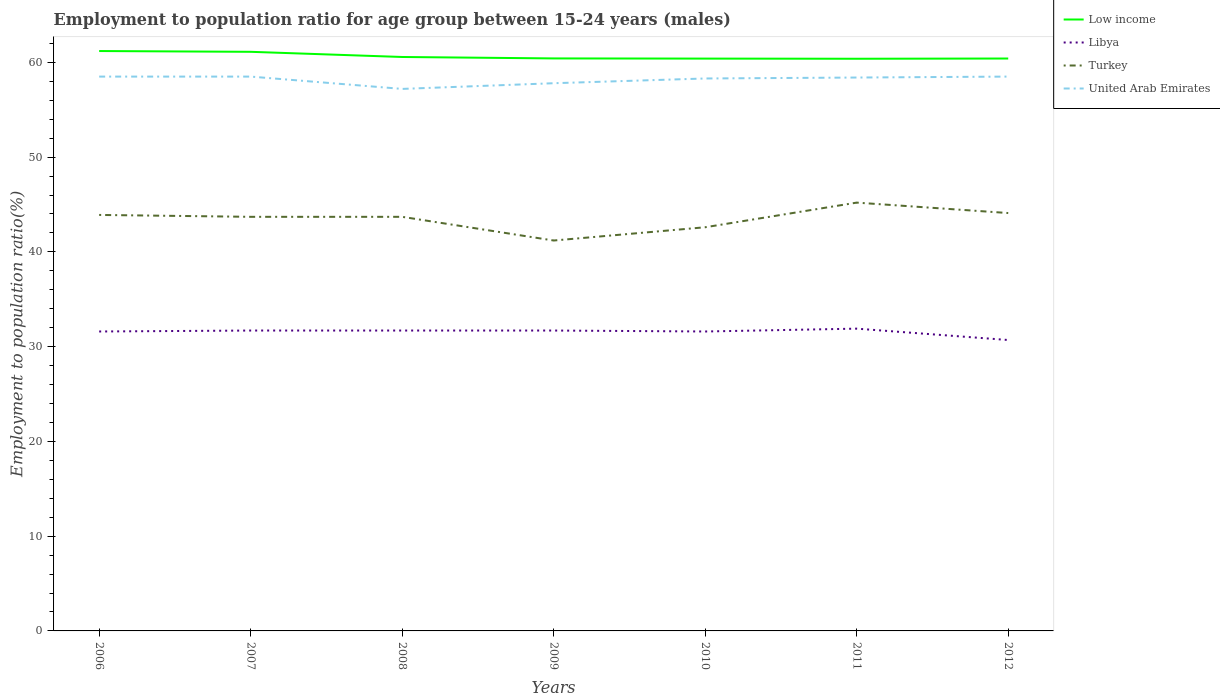How many different coloured lines are there?
Make the answer very short. 4. Is the number of lines equal to the number of legend labels?
Offer a terse response. Yes. Across all years, what is the maximum employment to population ratio in Turkey?
Make the answer very short. 41.2. In which year was the employment to population ratio in United Arab Emirates maximum?
Your response must be concise. 2008. What is the total employment to population ratio in Low income in the graph?
Provide a short and direct response. 0.15. What is the difference between the highest and the second highest employment to population ratio in Low income?
Offer a terse response. 0.82. Is the employment to population ratio in Turkey strictly greater than the employment to population ratio in United Arab Emirates over the years?
Offer a very short reply. Yes. How many years are there in the graph?
Offer a very short reply. 7. What is the difference between two consecutive major ticks on the Y-axis?
Offer a terse response. 10. Are the values on the major ticks of Y-axis written in scientific E-notation?
Provide a succinct answer. No. Does the graph contain any zero values?
Offer a terse response. No. How many legend labels are there?
Your answer should be compact. 4. How are the legend labels stacked?
Provide a succinct answer. Vertical. What is the title of the graph?
Ensure brevity in your answer.  Employment to population ratio for age group between 15-24 years (males). Does "Iran" appear as one of the legend labels in the graph?
Ensure brevity in your answer.  No. What is the label or title of the X-axis?
Offer a very short reply. Years. What is the Employment to population ratio(%) in Low income in 2006?
Make the answer very short. 61.2. What is the Employment to population ratio(%) of Libya in 2006?
Offer a terse response. 31.6. What is the Employment to population ratio(%) of Turkey in 2006?
Offer a very short reply. 43.9. What is the Employment to population ratio(%) in United Arab Emirates in 2006?
Your answer should be compact. 58.5. What is the Employment to population ratio(%) of Low income in 2007?
Your answer should be compact. 61.11. What is the Employment to population ratio(%) in Libya in 2007?
Make the answer very short. 31.7. What is the Employment to population ratio(%) in Turkey in 2007?
Your answer should be compact. 43.7. What is the Employment to population ratio(%) in United Arab Emirates in 2007?
Provide a short and direct response. 58.5. What is the Employment to population ratio(%) of Low income in 2008?
Keep it short and to the point. 60.57. What is the Employment to population ratio(%) of Libya in 2008?
Keep it short and to the point. 31.7. What is the Employment to population ratio(%) in Turkey in 2008?
Give a very brief answer. 43.7. What is the Employment to population ratio(%) in United Arab Emirates in 2008?
Your answer should be very brief. 57.2. What is the Employment to population ratio(%) in Low income in 2009?
Offer a very short reply. 60.42. What is the Employment to population ratio(%) of Libya in 2009?
Your response must be concise. 31.7. What is the Employment to population ratio(%) in Turkey in 2009?
Provide a succinct answer. 41.2. What is the Employment to population ratio(%) of United Arab Emirates in 2009?
Offer a very short reply. 57.8. What is the Employment to population ratio(%) in Low income in 2010?
Provide a short and direct response. 60.4. What is the Employment to population ratio(%) in Libya in 2010?
Offer a terse response. 31.6. What is the Employment to population ratio(%) in Turkey in 2010?
Keep it short and to the point. 42.6. What is the Employment to population ratio(%) in United Arab Emirates in 2010?
Give a very brief answer. 58.3. What is the Employment to population ratio(%) of Low income in 2011?
Offer a very short reply. 60.38. What is the Employment to population ratio(%) in Libya in 2011?
Provide a succinct answer. 31.9. What is the Employment to population ratio(%) in Turkey in 2011?
Your answer should be very brief. 45.2. What is the Employment to population ratio(%) of United Arab Emirates in 2011?
Your response must be concise. 58.4. What is the Employment to population ratio(%) in Low income in 2012?
Your answer should be compact. 60.41. What is the Employment to population ratio(%) in Libya in 2012?
Your response must be concise. 30.7. What is the Employment to population ratio(%) of Turkey in 2012?
Provide a succinct answer. 44.1. What is the Employment to population ratio(%) in United Arab Emirates in 2012?
Provide a short and direct response. 58.5. Across all years, what is the maximum Employment to population ratio(%) in Low income?
Your answer should be compact. 61.2. Across all years, what is the maximum Employment to population ratio(%) in Libya?
Offer a very short reply. 31.9. Across all years, what is the maximum Employment to population ratio(%) in Turkey?
Offer a terse response. 45.2. Across all years, what is the maximum Employment to population ratio(%) in United Arab Emirates?
Keep it short and to the point. 58.5. Across all years, what is the minimum Employment to population ratio(%) in Low income?
Your response must be concise. 60.38. Across all years, what is the minimum Employment to population ratio(%) in Libya?
Provide a short and direct response. 30.7. Across all years, what is the minimum Employment to population ratio(%) in Turkey?
Your answer should be very brief. 41.2. Across all years, what is the minimum Employment to population ratio(%) in United Arab Emirates?
Ensure brevity in your answer.  57.2. What is the total Employment to population ratio(%) in Low income in the graph?
Your answer should be very brief. 424.49. What is the total Employment to population ratio(%) of Libya in the graph?
Provide a succinct answer. 220.9. What is the total Employment to population ratio(%) in Turkey in the graph?
Make the answer very short. 304.4. What is the total Employment to population ratio(%) in United Arab Emirates in the graph?
Provide a short and direct response. 407.2. What is the difference between the Employment to population ratio(%) in Low income in 2006 and that in 2007?
Make the answer very short. 0.08. What is the difference between the Employment to population ratio(%) in Turkey in 2006 and that in 2007?
Your answer should be very brief. 0.2. What is the difference between the Employment to population ratio(%) in Low income in 2006 and that in 2008?
Give a very brief answer. 0.63. What is the difference between the Employment to population ratio(%) in Libya in 2006 and that in 2008?
Offer a terse response. -0.1. What is the difference between the Employment to population ratio(%) of United Arab Emirates in 2006 and that in 2008?
Provide a short and direct response. 1.3. What is the difference between the Employment to population ratio(%) of Low income in 2006 and that in 2009?
Offer a very short reply. 0.78. What is the difference between the Employment to population ratio(%) of Libya in 2006 and that in 2009?
Make the answer very short. -0.1. What is the difference between the Employment to population ratio(%) in Low income in 2006 and that in 2010?
Your answer should be compact. 0.8. What is the difference between the Employment to population ratio(%) in Libya in 2006 and that in 2010?
Provide a succinct answer. 0. What is the difference between the Employment to population ratio(%) in Low income in 2006 and that in 2011?
Your response must be concise. 0.82. What is the difference between the Employment to population ratio(%) of Libya in 2006 and that in 2011?
Provide a short and direct response. -0.3. What is the difference between the Employment to population ratio(%) of Turkey in 2006 and that in 2011?
Make the answer very short. -1.3. What is the difference between the Employment to population ratio(%) in Low income in 2006 and that in 2012?
Keep it short and to the point. 0.79. What is the difference between the Employment to population ratio(%) in Turkey in 2006 and that in 2012?
Keep it short and to the point. -0.2. What is the difference between the Employment to population ratio(%) of Low income in 2007 and that in 2008?
Give a very brief answer. 0.55. What is the difference between the Employment to population ratio(%) of Libya in 2007 and that in 2008?
Provide a succinct answer. 0. What is the difference between the Employment to population ratio(%) of Turkey in 2007 and that in 2008?
Provide a short and direct response. 0. What is the difference between the Employment to population ratio(%) of United Arab Emirates in 2007 and that in 2008?
Provide a succinct answer. 1.3. What is the difference between the Employment to population ratio(%) of Low income in 2007 and that in 2009?
Your answer should be compact. 0.7. What is the difference between the Employment to population ratio(%) in Turkey in 2007 and that in 2009?
Your answer should be compact. 2.5. What is the difference between the Employment to population ratio(%) of United Arab Emirates in 2007 and that in 2009?
Your answer should be compact. 0.7. What is the difference between the Employment to population ratio(%) in Low income in 2007 and that in 2010?
Give a very brief answer. 0.72. What is the difference between the Employment to population ratio(%) in United Arab Emirates in 2007 and that in 2010?
Keep it short and to the point. 0.2. What is the difference between the Employment to population ratio(%) of Low income in 2007 and that in 2011?
Give a very brief answer. 0.73. What is the difference between the Employment to population ratio(%) in Libya in 2007 and that in 2011?
Make the answer very short. -0.2. What is the difference between the Employment to population ratio(%) of Turkey in 2007 and that in 2011?
Your answer should be very brief. -1.5. What is the difference between the Employment to population ratio(%) in Low income in 2007 and that in 2012?
Offer a very short reply. 0.71. What is the difference between the Employment to population ratio(%) of Libya in 2007 and that in 2012?
Keep it short and to the point. 1. What is the difference between the Employment to population ratio(%) in Turkey in 2007 and that in 2012?
Offer a terse response. -0.4. What is the difference between the Employment to population ratio(%) of United Arab Emirates in 2007 and that in 2012?
Provide a short and direct response. 0. What is the difference between the Employment to population ratio(%) in Low income in 2008 and that in 2009?
Give a very brief answer. 0.15. What is the difference between the Employment to population ratio(%) of Libya in 2008 and that in 2009?
Keep it short and to the point. 0. What is the difference between the Employment to population ratio(%) of United Arab Emirates in 2008 and that in 2009?
Give a very brief answer. -0.6. What is the difference between the Employment to population ratio(%) in Low income in 2008 and that in 2010?
Give a very brief answer. 0.17. What is the difference between the Employment to population ratio(%) in Libya in 2008 and that in 2010?
Keep it short and to the point. 0.1. What is the difference between the Employment to population ratio(%) of United Arab Emirates in 2008 and that in 2010?
Provide a succinct answer. -1.1. What is the difference between the Employment to population ratio(%) of Low income in 2008 and that in 2011?
Offer a very short reply. 0.19. What is the difference between the Employment to population ratio(%) in Libya in 2008 and that in 2011?
Your answer should be very brief. -0.2. What is the difference between the Employment to population ratio(%) of Turkey in 2008 and that in 2011?
Your response must be concise. -1.5. What is the difference between the Employment to population ratio(%) in Low income in 2008 and that in 2012?
Make the answer very short. 0.16. What is the difference between the Employment to population ratio(%) of United Arab Emirates in 2008 and that in 2012?
Ensure brevity in your answer.  -1.3. What is the difference between the Employment to population ratio(%) in Low income in 2009 and that in 2010?
Make the answer very short. 0.02. What is the difference between the Employment to population ratio(%) of United Arab Emirates in 2009 and that in 2010?
Make the answer very short. -0.5. What is the difference between the Employment to population ratio(%) in Low income in 2009 and that in 2011?
Provide a succinct answer. 0.03. What is the difference between the Employment to population ratio(%) of Low income in 2009 and that in 2012?
Provide a short and direct response. 0.01. What is the difference between the Employment to population ratio(%) in Turkey in 2009 and that in 2012?
Provide a succinct answer. -2.9. What is the difference between the Employment to population ratio(%) in Low income in 2010 and that in 2011?
Provide a short and direct response. 0.02. What is the difference between the Employment to population ratio(%) in Turkey in 2010 and that in 2011?
Your response must be concise. -2.6. What is the difference between the Employment to population ratio(%) in United Arab Emirates in 2010 and that in 2011?
Your answer should be very brief. -0.1. What is the difference between the Employment to population ratio(%) in Low income in 2010 and that in 2012?
Your answer should be very brief. -0.01. What is the difference between the Employment to population ratio(%) in Libya in 2010 and that in 2012?
Provide a short and direct response. 0.9. What is the difference between the Employment to population ratio(%) of United Arab Emirates in 2010 and that in 2012?
Offer a very short reply. -0.2. What is the difference between the Employment to population ratio(%) in Low income in 2011 and that in 2012?
Provide a short and direct response. -0.02. What is the difference between the Employment to population ratio(%) in Libya in 2011 and that in 2012?
Your response must be concise. 1.2. What is the difference between the Employment to population ratio(%) in United Arab Emirates in 2011 and that in 2012?
Offer a terse response. -0.1. What is the difference between the Employment to population ratio(%) of Low income in 2006 and the Employment to population ratio(%) of Libya in 2007?
Your answer should be very brief. 29.5. What is the difference between the Employment to population ratio(%) in Low income in 2006 and the Employment to population ratio(%) in Turkey in 2007?
Your response must be concise. 17.5. What is the difference between the Employment to population ratio(%) in Low income in 2006 and the Employment to population ratio(%) in United Arab Emirates in 2007?
Make the answer very short. 2.7. What is the difference between the Employment to population ratio(%) in Libya in 2006 and the Employment to population ratio(%) in United Arab Emirates in 2007?
Offer a terse response. -26.9. What is the difference between the Employment to population ratio(%) in Turkey in 2006 and the Employment to population ratio(%) in United Arab Emirates in 2007?
Offer a very short reply. -14.6. What is the difference between the Employment to population ratio(%) of Low income in 2006 and the Employment to population ratio(%) of Libya in 2008?
Provide a succinct answer. 29.5. What is the difference between the Employment to population ratio(%) of Low income in 2006 and the Employment to population ratio(%) of Turkey in 2008?
Keep it short and to the point. 17.5. What is the difference between the Employment to population ratio(%) in Low income in 2006 and the Employment to population ratio(%) in United Arab Emirates in 2008?
Provide a short and direct response. 4. What is the difference between the Employment to population ratio(%) of Libya in 2006 and the Employment to population ratio(%) of Turkey in 2008?
Offer a terse response. -12.1. What is the difference between the Employment to population ratio(%) in Libya in 2006 and the Employment to population ratio(%) in United Arab Emirates in 2008?
Provide a short and direct response. -25.6. What is the difference between the Employment to population ratio(%) in Low income in 2006 and the Employment to population ratio(%) in Libya in 2009?
Your answer should be very brief. 29.5. What is the difference between the Employment to population ratio(%) of Low income in 2006 and the Employment to population ratio(%) of Turkey in 2009?
Your answer should be compact. 20. What is the difference between the Employment to population ratio(%) in Low income in 2006 and the Employment to population ratio(%) in United Arab Emirates in 2009?
Your answer should be very brief. 3.4. What is the difference between the Employment to population ratio(%) of Libya in 2006 and the Employment to population ratio(%) of United Arab Emirates in 2009?
Your answer should be compact. -26.2. What is the difference between the Employment to population ratio(%) of Turkey in 2006 and the Employment to population ratio(%) of United Arab Emirates in 2009?
Make the answer very short. -13.9. What is the difference between the Employment to population ratio(%) in Low income in 2006 and the Employment to population ratio(%) in Libya in 2010?
Make the answer very short. 29.6. What is the difference between the Employment to population ratio(%) of Low income in 2006 and the Employment to population ratio(%) of Turkey in 2010?
Ensure brevity in your answer.  18.6. What is the difference between the Employment to population ratio(%) in Low income in 2006 and the Employment to population ratio(%) in United Arab Emirates in 2010?
Make the answer very short. 2.9. What is the difference between the Employment to population ratio(%) in Libya in 2006 and the Employment to population ratio(%) in Turkey in 2010?
Provide a succinct answer. -11. What is the difference between the Employment to population ratio(%) of Libya in 2006 and the Employment to population ratio(%) of United Arab Emirates in 2010?
Give a very brief answer. -26.7. What is the difference between the Employment to population ratio(%) in Turkey in 2006 and the Employment to population ratio(%) in United Arab Emirates in 2010?
Keep it short and to the point. -14.4. What is the difference between the Employment to population ratio(%) of Low income in 2006 and the Employment to population ratio(%) of Libya in 2011?
Provide a succinct answer. 29.3. What is the difference between the Employment to population ratio(%) of Low income in 2006 and the Employment to population ratio(%) of Turkey in 2011?
Make the answer very short. 16. What is the difference between the Employment to population ratio(%) in Low income in 2006 and the Employment to population ratio(%) in United Arab Emirates in 2011?
Offer a terse response. 2.8. What is the difference between the Employment to population ratio(%) in Libya in 2006 and the Employment to population ratio(%) in United Arab Emirates in 2011?
Your response must be concise. -26.8. What is the difference between the Employment to population ratio(%) of Low income in 2006 and the Employment to population ratio(%) of Libya in 2012?
Provide a short and direct response. 30.5. What is the difference between the Employment to population ratio(%) in Low income in 2006 and the Employment to population ratio(%) in Turkey in 2012?
Keep it short and to the point. 17.1. What is the difference between the Employment to population ratio(%) of Low income in 2006 and the Employment to population ratio(%) of United Arab Emirates in 2012?
Offer a terse response. 2.7. What is the difference between the Employment to population ratio(%) in Libya in 2006 and the Employment to population ratio(%) in Turkey in 2012?
Offer a very short reply. -12.5. What is the difference between the Employment to population ratio(%) of Libya in 2006 and the Employment to population ratio(%) of United Arab Emirates in 2012?
Your response must be concise. -26.9. What is the difference between the Employment to population ratio(%) in Turkey in 2006 and the Employment to population ratio(%) in United Arab Emirates in 2012?
Give a very brief answer. -14.6. What is the difference between the Employment to population ratio(%) of Low income in 2007 and the Employment to population ratio(%) of Libya in 2008?
Your answer should be compact. 29.41. What is the difference between the Employment to population ratio(%) in Low income in 2007 and the Employment to population ratio(%) in Turkey in 2008?
Ensure brevity in your answer.  17.41. What is the difference between the Employment to population ratio(%) of Low income in 2007 and the Employment to population ratio(%) of United Arab Emirates in 2008?
Offer a very short reply. 3.91. What is the difference between the Employment to population ratio(%) of Libya in 2007 and the Employment to population ratio(%) of United Arab Emirates in 2008?
Your response must be concise. -25.5. What is the difference between the Employment to population ratio(%) of Low income in 2007 and the Employment to population ratio(%) of Libya in 2009?
Your response must be concise. 29.41. What is the difference between the Employment to population ratio(%) of Low income in 2007 and the Employment to population ratio(%) of Turkey in 2009?
Keep it short and to the point. 19.91. What is the difference between the Employment to population ratio(%) in Low income in 2007 and the Employment to population ratio(%) in United Arab Emirates in 2009?
Provide a succinct answer. 3.31. What is the difference between the Employment to population ratio(%) in Libya in 2007 and the Employment to population ratio(%) in Turkey in 2009?
Offer a terse response. -9.5. What is the difference between the Employment to population ratio(%) of Libya in 2007 and the Employment to population ratio(%) of United Arab Emirates in 2009?
Give a very brief answer. -26.1. What is the difference between the Employment to population ratio(%) in Turkey in 2007 and the Employment to population ratio(%) in United Arab Emirates in 2009?
Your response must be concise. -14.1. What is the difference between the Employment to population ratio(%) in Low income in 2007 and the Employment to population ratio(%) in Libya in 2010?
Give a very brief answer. 29.51. What is the difference between the Employment to population ratio(%) in Low income in 2007 and the Employment to population ratio(%) in Turkey in 2010?
Make the answer very short. 18.51. What is the difference between the Employment to population ratio(%) of Low income in 2007 and the Employment to population ratio(%) of United Arab Emirates in 2010?
Provide a short and direct response. 2.81. What is the difference between the Employment to population ratio(%) of Libya in 2007 and the Employment to population ratio(%) of Turkey in 2010?
Provide a succinct answer. -10.9. What is the difference between the Employment to population ratio(%) in Libya in 2007 and the Employment to population ratio(%) in United Arab Emirates in 2010?
Provide a succinct answer. -26.6. What is the difference between the Employment to population ratio(%) of Turkey in 2007 and the Employment to population ratio(%) of United Arab Emirates in 2010?
Ensure brevity in your answer.  -14.6. What is the difference between the Employment to population ratio(%) of Low income in 2007 and the Employment to population ratio(%) of Libya in 2011?
Offer a very short reply. 29.21. What is the difference between the Employment to population ratio(%) of Low income in 2007 and the Employment to population ratio(%) of Turkey in 2011?
Offer a terse response. 15.91. What is the difference between the Employment to population ratio(%) in Low income in 2007 and the Employment to population ratio(%) in United Arab Emirates in 2011?
Your answer should be compact. 2.71. What is the difference between the Employment to population ratio(%) in Libya in 2007 and the Employment to population ratio(%) in Turkey in 2011?
Keep it short and to the point. -13.5. What is the difference between the Employment to population ratio(%) in Libya in 2007 and the Employment to population ratio(%) in United Arab Emirates in 2011?
Your response must be concise. -26.7. What is the difference between the Employment to population ratio(%) in Turkey in 2007 and the Employment to population ratio(%) in United Arab Emirates in 2011?
Provide a short and direct response. -14.7. What is the difference between the Employment to population ratio(%) in Low income in 2007 and the Employment to population ratio(%) in Libya in 2012?
Provide a succinct answer. 30.41. What is the difference between the Employment to population ratio(%) in Low income in 2007 and the Employment to population ratio(%) in Turkey in 2012?
Offer a very short reply. 17.01. What is the difference between the Employment to population ratio(%) of Low income in 2007 and the Employment to population ratio(%) of United Arab Emirates in 2012?
Give a very brief answer. 2.61. What is the difference between the Employment to population ratio(%) in Libya in 2007 and the Employment to population ratio(%) in Turkey in 2012?
Keep it short and to the point. -12.4. What is the difference between the Employment to population ratio(%) in Libya in 2007 and the Employment to population ratio(%) in United Arab Emirates in 2012?
Your response must be concise. -26.8. What is the difference between the Employment to population ratio(%) in Turkey in 2007 and the Employment to population ratio(%) in United Arab Emirates in 2012?
Your answer should be very brief. -14.8. What is the difference between the Employment to population ratio(%) in Low income in 2008 and the Employment to population ratio(%) in Libya in 2009?
Keep it short and to the point. 28.87. What is the difference between the Employment to population ratio(%) in Low income in 2008 and the Employment to population ratio(%) in Turkey in 2009?
Give a very brief answer. 19.37. What is the difference between the Employment to population ratio(%) in Low income in 2008 and the Employment to population ratio(%) in United Arab Emirates in 2009?
Your answer should be compact. 2.77. What is the difference between the Employment to population ratio(%) of Libya in 2008 and the Employment to population ratio(%) of United Arab Emirates in 2009?
Your answer should be compact. -26.1. What is the difference between the Employment to population ratio(%) in Turkey in 2008 and the Employment to population ratio(%) in United Arab Emirates in 2009?
Ensure brevity in your answer.  -14.1. What is the difference between the Employment to population ratio(%) of Low income in 2008 and the Employment to population ratio(%) of Libya in 2010?
Provide a succinct answer. 28.97. What is the difference between the Employment to population ratio(%) of Low income in 2008 and the Employment to population ratio(%) of Turkey in 2010?
Your answer should be compact. 17.97. What is the difference between the Employment to population ratio(%) in Low income in 2008 and the Employment to population ratio(%) in United Arab Emirates in 2010?
Make the answer very short. 2.27. What is the difference between the Employment to population ratio(%) of Libya in 2008 and the Employment to population ratio(%) of Turkey in 2010?
Ensure brevity in your answer.  -10.9. What is the difference between the Employment to population ratio(%) of Libya in 2008 and the Employment to population ratio(%) of United Arab Emirates in 2010?
Offer a terse response. -26.6. What is the difference between the Employment to population ratio(%) in Turkey in 2008 and the Employment to population ratio(%) in United Arab Emirates in 2010?
Keep it short and to the point. -14.6. What is the difference between the Employment to population ratio(%) of Low income in 2008 and the Employment to population ratio(%) of Libya in 2011?
Offer a very short reply. 28.67. What is the difference between the Employment to population ratio(%) in Low income in 2008 and the Employment to population ratio(%) in Turkey in 2011?
Ensure brevity in your answer.  15.37. What is the difference between the Employment to population ratio(%) of Low income in 2008 and the Employment to population ratio(%) of United Arab Emirates in 2011?
Provide a succinct answer. 2.17. What is the difference between the Employment to population ratio(%) of Libya in 2008 and the Employment to population ratio(%) of Turkey in 2011?
Your answer should be very brief. -13.5. What is the difference between the Employment to population ratio(%) of Libya in 2008 and the Employment to population ratio(%) of United Arab Emirates in 2011?
Your answer should be compact. -26.7. What is the difference between the Employment to population ratio(%) in Turkey in 2008 and the Employment to population ratio(%) in United Arab Emirates in 2011?
Ensure brevity in your answer.  -14.7. What is the difference between the Employment to population ratio(%) of Low income in 2008 and the Employment to population ratio(%) of Libya in 2012?
Offer a terse response. 29.87. What is the difference between the Employment to population ratio(%) of Low income in 2008 and the Employment to population ratio(%) of Turkey in 2012?
Ensure brevity in your answer.  16.47. What is the difference between the Employment to population ratio(%) in Low income in 2008 and the Employment to population ratio(%) in United Arab Emirates in 2012?
Your response must be concise. 2.07. What is the difference between the Employment to population ratio(%) in Libya in 2008 and the Employment to population ratio(%) in Turkey in 2012?
Keep it short and to the point. -12.4. What is the difference between the Employment to population ratio(%) of Libya in 2008 and the Employment to population ratio(%) of United Arab Emirates in 2012?
Your answer should be compact. -26.8. What is the difference between the Employment to population ratio(%) in Turkey in 2008 and the Employment to population ratio(%) in United Arab Emirates in 2012?
Offer a terse response. -14.8. What is the difference between the Employment to population ratio(%) in Low income in 2009 and the Employment to population ratio(%) in Libya in 2010?
Make the answer very short. 28.82. What is the difference between the Employment to population ratio(%) in Low income in 2009 and the Employment to population ratio(%) in Turkey in 2010?
Offer a very short reply. 17.82. What is the difference between the Employment to population ratio(%) in Low income in 2009 and the Employment to population ratio(%) in United Arab Emirates in 2010?
Provide a short and direct response. 2.12. What is the difference between the Employment to population ratio(%) in Libya in 2009 and the Employment to population ratio(%) in United Arab Emirates in 2010?
Keep it short and to the point. -26.6. What is the difference between the Employment to population ratio(%) in Turkey in 2009 and the Employment to population ratio(%) in United Arab Emirates in 2010?
Your answer should be very brief. -17.1. What is the difference between the Employment to population ratio(%) of Low income in 2009 and the Employment to population ratio(%) of Libya in 2011?
Your response must be concise. 28.52. What is the difference between the Employment to population ratio(%) in Low income in 2009 and the Employment to population ratio(%) in Turkey in 2011?
Provide a short and direct response. 15.22. What is the difference between the Employment to population ratio(%) in Low income in 2009 and the Employment to population ratio(%) in United Arab Emirates in 2011?
Provide a succinct answer. 2.02. What is the difference between the Employment to population ratio(%) of Libya in 2009 and the Employment to population ratio(%) of United Arab Emirates in 2011?
Your answer should be very brief. -26.7. What is the difference between the Employment to population ratio(%) of Turkey in 2009 and the Employment to population ratio(%) of United Arab Emirates in 2011?
Keep it short and to the point. -17.2. What is the difference between the Employment to population ratio(%) of Low income in 2009 and the Employment to population ratio(%) of Libya in 2012?
Offer a very short reply. 29.72. What is the difference between the Employment to population ratio(%) in Low income in 2009 and the Employment to population ratio(%) in Turkey in 2012?
Ensure brevity in your answer.  16.32. What is the difference between the Employment to population ratio(%) in Low income in 2009 and the Employment to population ratio(%) in United Arab Emirates in 2012?
Keep it short and to the point. 1.92. What is the difference between the Employment to population ratio(%) of Libya in 2009 and the Employment to population ratio(%) of United Arab Emirates in 2012?
Your answer should be very brief. -26.8. What is the difference between the Employment to population ratio(%) in Turkey in 2009 and the Employment to population ratio(%) in United Arab Emirates in 2012?
Provide a succinct answer. -17.3. What is the difference between the Employment to population ratio(%) of Low income in 2010 and the Employment to population ratio(%) of Libya in 2011?
Keep it short and to the point. 28.5. What is the difference between the Employment to population ratio(%) of Low income in 2010 and the Employment to population ratio(%) of Turkey in 2011?
Your answer should be compact. 15.2. What is the difference between the Employment to population ratio(%) of Low income in 2010 and the Employment to population ratio(%) of United Arab Emirates in 2011?
Your answer should be compact. 2. What is the difference between the Employment to population ratio(%) of Libya in 2010 and the Employment to population ratio(%) of Turkey in 2011?
Keep it short and to the point. -13.6. What is the difference between the Employment to population ratio(%) in Libya in 2010 and the Employment to population ratio(%) in United Arab Emirates in 2011?
Make the answer very short. -26.8. What is the difference between the Employment to population ratio(%) in Turkey in 2010 and the Employment to population ratio(%) in United Arab Emirates in 2011?
Your answer should be very brief. -15.8. What is the difference between the Employment to population ratio(%) in Low income in 2010 and the Employment to population ratio(%) in Libya in 2012?
Your answer should be compact. 29.7. What is the difference between the Employment to population ratio(%) in Low income in 2010 and the Employment to population ratio(%) in Turkey in 2012?
Ensure brevity in your answer.  16.3. What is the difference between the Employment to population ratio(%) of Low income in 2010 and the Employment to population ratio(%) of United Arab Emirates in 2012?
Keep it short and to the point. 1.9. What is the difference between the Employment to population ratio(%) in Libya in 2010 and the Employment to population ratio(%) in United Arab Emirates in 2012?
Ensure brevity in your answer.  -26.9. What is the difference between the Employment to population ratio(%) in Turkey in 2010 and the Employment to population ratio(%) in United Arab Emirates in 2012?
Provide a succinct answer. -15.9. What is the difference between the Employment to population ratio(%) in Low income in 2011 and the Employment to population ratio(%) in Libya in 2012?
Keep it short and to the point. 29.68. What is the difference between the Employment to population ratio(%) of Low income in 2011 and the Employment to population ratio(%) of Turkey in 2012?
Keep it short and to the point. 16.28. What is the difference between the Employment to population ratio(%) of Low income in 2011 and the Employment to population ratio(%) of United Arab Emirates in 2012?
Provide a succinct answer. 1.88. What is the difference between the Employment to population ratio(%) in Libya in 2011 and the Employment to population ratio(%) in United Arab Emirates in 2012?
Your response must be concise. -26.6. What is the average Employment to population ratio(%) in Low income per year?
Provide a short and direct response. 60.64. What is the average Employment to population ratio(%) in Libya per year?
Ensure brevity in your answer.  31.56. What is the average Employment to population ratio(%) in Turkey per year?
Provide a succinct answer. 43.49. What is the average Employment to population ratio(%) in United Arab Emirates per year?
Your answer should be very brief. 58.17. In the year 2006, what is the difference between the Employment to population ratio(%) in Low income and Employment to population ratio(%) in Libya?
Provide a short and direct response. 29.6. In the year 2006, what is the difference between the Employment to population ratio(%) in Low income and Employment to population ratio(%) in Turkey?
Offer a terse response. 17.3. In the year 2006, what is the difference between the Employment to population ratio(%) in Low income and Employment to population ratio(%) in United Arab Emirates?
Ensure brevity in your answer.  2.7. In the year 2006, what is the difference between the Employment to population ratio(%) in Libya and Employment to population ratio(%) in Turkey?
Offer a terse response. -12.3. In the year 2006, what is the difference between the Employment to population ratio(%) of Libya and Employment to population ratio(%) of United Arab Emirates?
Provide a short and direct response. -26.9. In the year 2006, what is the difference between the Employment to population ratio(%) of Turkey and Employment to population ratio(%) of United Arab Emirates?
Give a very brief answer. -14.6. In the year 2007, what is the difference between the Employment to population ratio(%) in Low income and Employment to population ratio(%) in Libya?
Offer a very short reply. 29.41. In the year 2007, what is the difference between the Employment to population ratio(%) in Low income and Employment to population ratio(%) in Turkey?
Provide a short and direct response. 17.41. In the year 2007, what is the difference between the Employment to population ratio(%) in Low income and Employment to population ratio(%) in United Arab Emirates?
Keep it short and to the point. 2.61. In the year 2007, what is the difference between the Employment to population ratio(%) of Libya and Employment to population ratio(%) of Turkey?
Make the answer very short. -12. In the year 2007, what is the difference between the Employment to population ratio(%) of Libya and Employment to population ratio(%) of United Arab Emirates?
Offer a terse response. -26.8. In the year 2007, what is the difference between the Employment to population ratio(%) in Turkey and Employment to population ratio(%) in United Arab Emirates?
Your answer should be very brief. -14.8. In the year 2008, what is the difference between the Employment to population ratio(%) of Low income and Employment to population ratio(%) of Libya?
Ensure brevity in your answer.  28.87. In the year 2008, what is the difference between the Employment to population ratio(%) of Low income and Employment to population ratio(%) of Turkey?
Provide a succinct answer. 16.87. In the year 2008, what is the difference between the Employment to population ratio(%) in Low income and Employment to population ratio(%) in United Arab Emirates?
Your answer should be compact. 3.37. In the year 2008, what is the difference between the Employment to population ratio(%) in Libya and Employment to population ratio(%) in Turkey?
Offer a terse response. -12. In the year 2008, what is the difference between the Employment to population ratio(%) of Libya and Employment to population ratio(%) of United Arab Emirates?
Your answer should be compact. -25.5. In the year 2008, what is the difference between the Employment to population ratio(%) of Turkey and Employment to population ratio(%) of United Arab Emirates?
Your response must be concise. -13.5. In the year 2009, what is the difference between the Employment to population ratio(%) in Low income and Employment to population ratio(%) in Libya?
Offer a terse response. 28.72. In the year 2009, what is the difference between the Employment to population ratio(%) in Low income and Employment to population ratio(%) in Turkey?
Make the answer very short. 19.22. In the year 2009, what is the difference between the Employment to population ratio(%) in Low income and Employment to population ratio(%) in United Arab Emirates?
Your answer should be compact. 2.62. In the year 2009, what is the difference between the Employment to population ratio(%) in Libya and Employment to population ratio(%) in Turkey?
Give a very brief answer. -9.5. In the year 2009, what is the difference between the Employment to population ratio(%) in Libya and Employment to population ratio(%) in United Arab Emirates?
Offer a very short reply. -26.1. In the year 2009, what is the difference between the Employment to population ratio(%) in Turkey and Employment to population ratio(%) in United Arab Emirates?
Your answer should be compact. -16.6. In the year 2010, what is the difference between the Employment to population ratio(%) in Low income and Employment to population ratio(%) in Libya?
Make the answer very short. 28.8. In the year 2010, what is the difference between the Employment to population ratio(%) of Low income and Employment to population ratio(%) of Turkey?
Your answer should be very brief. 17.8. In the year 2010, what is the difference between the Employment to population ratio(%) of Low income and Employment to population ratio(%) of United Arab Emirates?
Offer a terse response. 2.1. In the year 2010, what is the difference between the Employment to population ratio(%) of Libya and Employment to population ratio(%) of Turkey?
Ensure brevity in your answer.  -11. In the year 2010, what is the difference between the Employment to population ratio(%) of Libya and Employment to population ratio(%) of United Arab Emirates?
Give a very brief answer. -26.7. In the year 2010, what is the difference between the Employment to population ratio(%) in Turkey and Employment to population ratio(%) in United Arab Emirates?
Provide a succinct answer. -15.7. In the year 2011, what is the difference between the Employment to population ratio(%) in Low income and Employment to population ratio(%) in Libya?
Offer a very short reply. 28.48. In the year 2011, what is the difference between the Employment to population ratio(%) in Low income and Employment to population ratio(%) in Turkey?
Offer a very short reply. 15.18. In the year 2011, what is the difference between the Employment to population ratio(%) of Low income and Employment to population ratio(%) of United Arab Emirates?
Ensure brevity in your answer.  1.98. In the year 2011, what is the difference between the Employment to population ratio(%) of Libya and Employment to population ratio(%) of Turkey?
Your answer should be compact. -13.3. In the year 2011, what is the difference between the Employment to population ratio(%) in Libya and Employment to population ratio(%) in United Arab Emirates?
Make the answer very short. -26.5. In the year 2011, what is the difference between the Employment to population ratio(%) in Turkey and Employment to population ratio(%) in United Arab Emirates?
Keep it short and to the point. -13.2. In the year 2012, what is the difference between the Employment to population ratio(%) in Low income and Employment to population ratio(%) in Libya?
Make the answer very short. 29.71. In the year 2012, what is the difference between the Employment to population ratio(%) in Low income and Employment to population ratio(%) in Turkey?
Make the answer very short. 16.31. In the year 2012, what is the difference between the Employment to population ratio(%) of Low income and Employment to population ratio(%) of United Arab Emirates?
Offer a terse response. 1.91. In the year 2012, what is the difference between the Employment to population ratio(%) in Libya and Employment to population ratio(%) in United Arab Emirates?
Offer a terse response. -27.8. In the year 2012, what is the difference between the Employment to population ratio(%) in Turkey and Employment to population ratio(%) in United Arab Emirates?
Provide a succinct answer. -14.4. What is the ratio of the Employment to population ratio(%) of Low income in 2006 to that in 2007?
Keep it short and to the point. 1. What is the ratio of the Employment to population ratio(%) of Turkey in 2006 to that in 2007?
Your response must be concise. 1. What is the ratio of the Employment to population ratio(%) of United Arab Emirates in 2006 to that in 2007?
Offer a terse response. 1. What is the ratio of the Employment to population ratio(%) in Low income in 2006 to that in 2008?
Your response must be concise. 1.01. What is the ratio of the Employment to population ratio(%) of United Arab Emirates in 2006 to that in 2008?
Offer a very short reply. 1.02. What is the ratio of the Employment to population ratio(%) in Low income in 2006 to that in 2009?
Give a very brief answer. 1.01. What is the ratio of the Employment to population ratio(%) of Turkey in 2006 to that in 2009?
Keep it short and to the point. 1.07. What is the ratio of the Employment to population ratio(%) of United Arab Emirates in 2006 to that in 2009?
Offer a terse response. 1.01. What is the ratio of the Employment to population ratio(%) in Low income in 2006 to that in 2010?
Your answer should be very brief. 1.01. What is the ratio of the Employment to population ratio(%) of Turkey in 2006 to that in 2010?
Offer a very short reply. 1.03. What is the ratio of the Employment to population ratio(%) of Low income in 2006 to that in 2011?
Give a very brief answer. 1.01. What is the ratio of the Employment to population ratio(%) of Libya in 2006 to that in 2011?
Your answer should be very brief. 0.99. What is the ratio of the Employment to population ratio(%) of Turkey in 2006 to that in 2011?
Offer a terse response. 0.97. What is the ratio of the Employment to population ratio(%) in United Arab Emirates in 2006 to that in 2011?
Keep it short and to the point. 1. What is the ratio of the Employment to population ratio(%) of Low income in 2006 to that in 2012?
Give a very brief answer. 1.01. What is the ratio of the Employment to population ratio(%) of Libya in 2006 to that in 2012?
Provide a short and direct response. 1.03. What is the ratio of the Employment to population ratio(%) of Turkey in 2006 to that in 2012?
Give a very brief answer. 1. What is the ratio of the Employment to population ratio(%) in United Arab Emirates in 2006 to that in 2012?
Offer a very short reply. 1. What is the ratio of the Employment to population ratio(%) of Libya in 2007 to that in 2008?
Keep it short and to the point. 1. What is the ratio of the Employment to population ratio(%) of United Arab Emirates in 2007 to that in 2008?
Offer a terse response. 1.02. What is the ratio of the Employment to population ratio(%) in Low income in 2007 to that in 2009?
Provide a short and direct response. 1.01. What is the ratio of the Employment to population ratio(%) of Libya in 2007 to that in 2009?
Make the answer very short. 1. What is the ratio of the Employment to population ratio(%) in Turkey in 2007 to that in 2009?
Provide a short and direct response. 1.06. What is the ratio of the Employment to population ratio(%) in United Arab Emirates in 2007 to that in 2009?
Keep it short and to the point. 1.01. What is the ratio of the Employment to population ratio(%) in Low income in 2007 to that in 2010?
Give a very brief answer. 1.01. What is the ratio of the Employment to population ratio(%) of Libya in 2007 to that in 2010?
Your answer should be very brief. 1. What is the ratio of the Employment to population ratio(%) in Turkey in 2007 to that in 2010?
Offer a very short reply. 1.03. What is the ratio of the Employment to population ratio(%) in United Arab Emirates in 2007 to that in 2010?
Keep it short and to the point. 1. What is the ratio of the Employment to population ratio(%) in Low income in 2007 to that in 2011?
Ensure brevity in your answer.  1.01. What is the ratio of the Employment to population ratio(%) of Turkey in 2007 to that in 2011?
Make the answer very short. 0.97. What is the ratio of the Employment to population ratio(%) of United Arab Emirates in 2007 to that in 2011?
Your answer should be compact. 1. What is the ratio of the Employment to population ratio(%) of Low income in 2007 to that in 2012?
Ensure brevity in your answer.  1.01. What is the ratio of the Employment to population ratio(%) in Libya in 2007 to that in 2012?
Your answer should be very brief. 1.03. What is the ratio of the Employment to population ratio(%) in Turkey in 2007 to that in 2012?
Provide a succinct answer. 0.99. What is the ratio of the Employment to population ratio(%) in Low income in 2008 to that in 2009?
Your answer should be compact. 1. What is the ratio of the Employment to population ratio(%) in Libya in 2008 to that in 2009?
Offer a very short reply. 1. What is the ratio of the Employment to population ratio(%) of Turkey in 2008 to that in 2009?
Offer a terse response. 1.06. What is the ratio of the Employment to population ratio(%) of United Arab Emirates in 2008 to that in 2009?
Your answer should be very brief. 0.99. What is the ratio of the Employment to population ratio(%) of Turkey in 2008 to that in 2010?
Offer a terse response. 1.03. What is the ratio of the Employment to population ratio(%) of United Arab Emirates in 2008 to that in 2010?
Your answer should be very brief. 0.98. What is the ratio of the Employment to population ratio(%) in Low income in 2008 to that in 2011?
Your answer should be very brief. 1. What is the ratio of the Employment to population ratio(%) of Turkey in 2008 to that in 2011?
Your response must be concise. 0.97. What is the ratio of the Employment to population ratio(%) in United Arab Emirates in 2008 to that in 2011?
Your answer should be compact. 0.98. What is the ratio of the Employment to population ratio(%) of Low income in 2008 to that in 2012?
Provide a succinct answer. 1. What is the ratio of the Employment to population ratio(%) in Libya in 2008 to that in 2012?
Your response must be concise. 1.03. What is the ratio of the Employment to population ratio(%) of Turkey in 2008 to that in 2012?
Offer a very short reply. 0.99. What is the ratio of the Employment to population ratio(%) of United Arab Emirates in 2008 to that in 2012?
Give a very brief answer. 0.98. What is the ratio of the Employment to population ratio(%) of Low income in 2009 to that in 2010?
Your response must be concise. 1. What is the ratio of the Employment to population ratio(%) in Turkey in 2009 to that in 2010?
Provide a succinct answer. 0.97. What is the ratio of the Employment to population ratio(%) in Turkey in 2009 to that in 2011?
Your response must be concise. 0.91. What is the ratio of the Employment to population ratio(%) of United Arab Emirates in 2009 to that in 2011?
Offer a terse response. 0.99. What is the ratio of the Employment to population ratio(%) of Libya in 2009 to that in 2012?
Your answer should be compact. 1.03. What is the ratio of the Employment to population ratio(%) in Turkey in 2009 to that in 2012?
Offer a terse response. 0.93. What is the ratio of the Employment to population ratio(%) in Low income in 2010 to that in 2011?
Offer a terse response. 1. What is the ratio of the Employment to population ratio(%) of Libya in 2010 to that in 2011?
Ensure brevity in your answer.  0.99. What is the ratio of the Employment to population ratio(%) of Turkey in 2010 to that in 2011?
Make the answer very short. 0.94. What is the ratio of the Employment to population ratio(%) in Low income in 2010 to that in 2012?
Your answer should be very brief. 1. What is the ratio of the Employment to population ratio(%) in Libya in 2010 to that in 2012?
Give a very brief answer. 1.03. What is the ratio of the Employment to population ratio(%) in United Arab Emirates in 2010 to that in 2012?
Ensure brevity in your answer.  1. What is the ratio of the Employment to population ratio(%) of Libya in 2011 to that in 2012?
Your answer should be compact. 1.04. What is the ratio of the Employment to population ratio(%) of Turkey in 2011 to that in 2012?
Give a very brief answer. 1.02. What is the difference between the highest and the second highest Employment to population ratio(%) of Low income?
Provide a succinct answer. 0.08. What is the difference between the highest and the second highest Employment to population ratio(%) of Libya?
Ensure brevity in your answer.  0.2. What is the difference between the highest and the second highest Employment to population ratio(%) in United Arab Emirates?
Give a very brief answer. 0. What is the difference between the highest and the lowest Employment to population ratio(%) in Low income?
Give a very brief answer. 0.82. What is the difference between the highest and the lowest Employment to population ratio(%) of Libya?
Provide a short and direct response. 1.2. What is the difference between the highest and the lowest Employment to population ratio(%) in United Arab Emirates?
Keep it short and to the point. 1.3. 